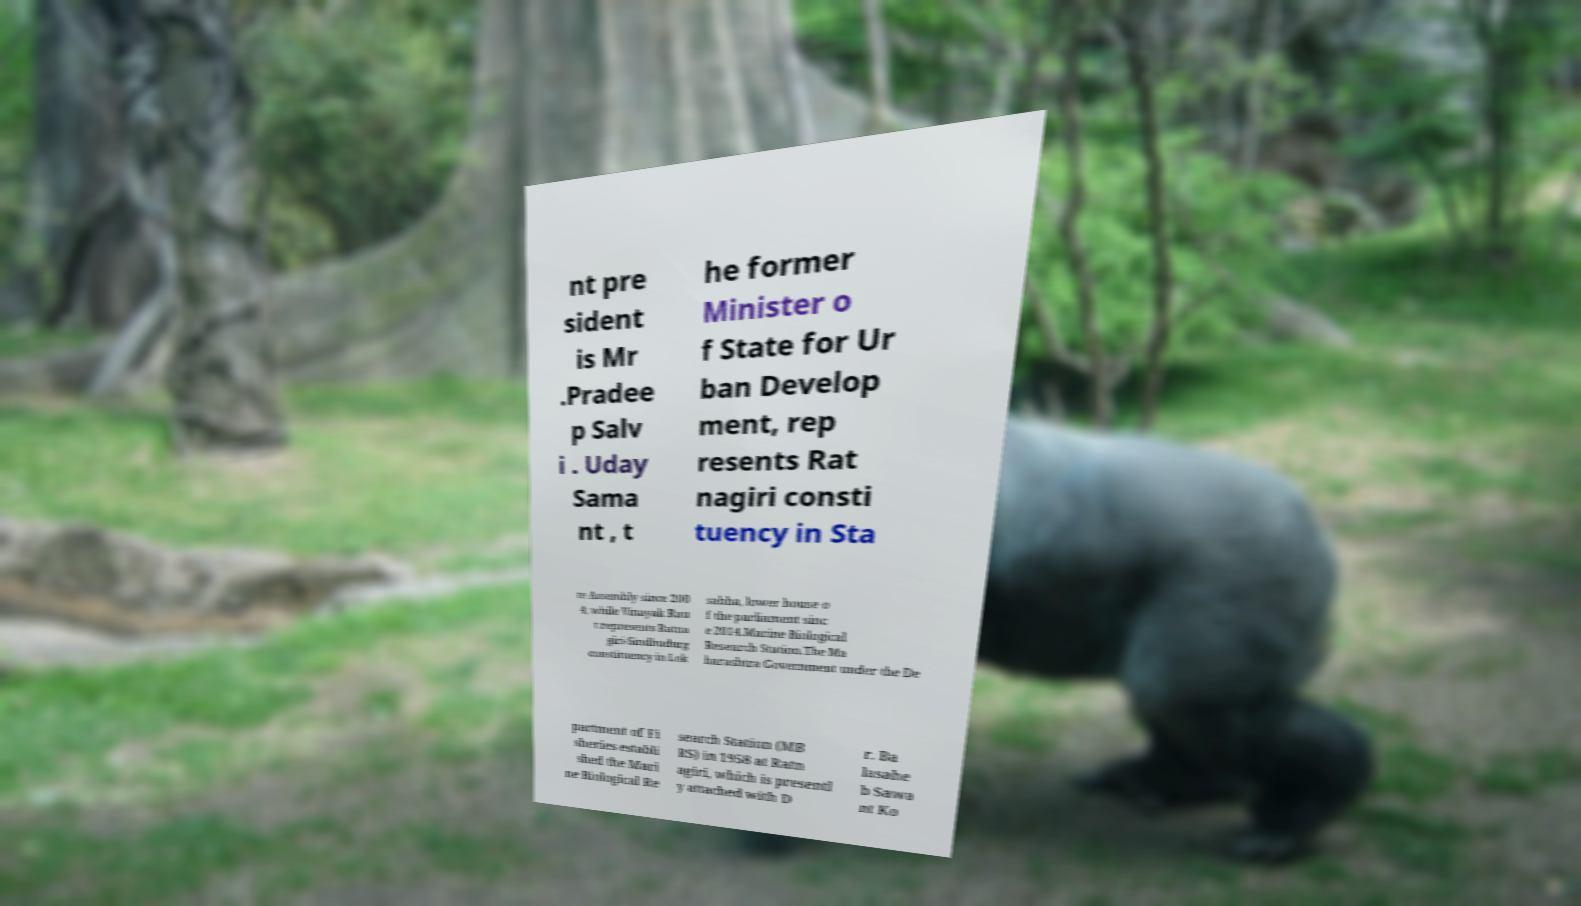Can you accurately transcribe the text from the provided image for me? nt pre sident is Mr .Pradee p Salv i . Uday Sama nt , t he former Minister o f State for Ur ban Develop ment, rep resents Rat nagiri consti tuency in Sta te Assembly since 200 4; while Vinayak Rau t represents Ratna giri-Sindhudurg constituency in Lok sabha, lower house o f the parliament sinc e 2014.Marine Biological Research Station.The Ma harashtra Government under the De partment of Fi sheries establi shed the Mari ne Biological Re search Station (MB RS) in 1958 at Ratn agiri, which is presentl y attached with D r. Ba lasahe b Sawa nt Ko 